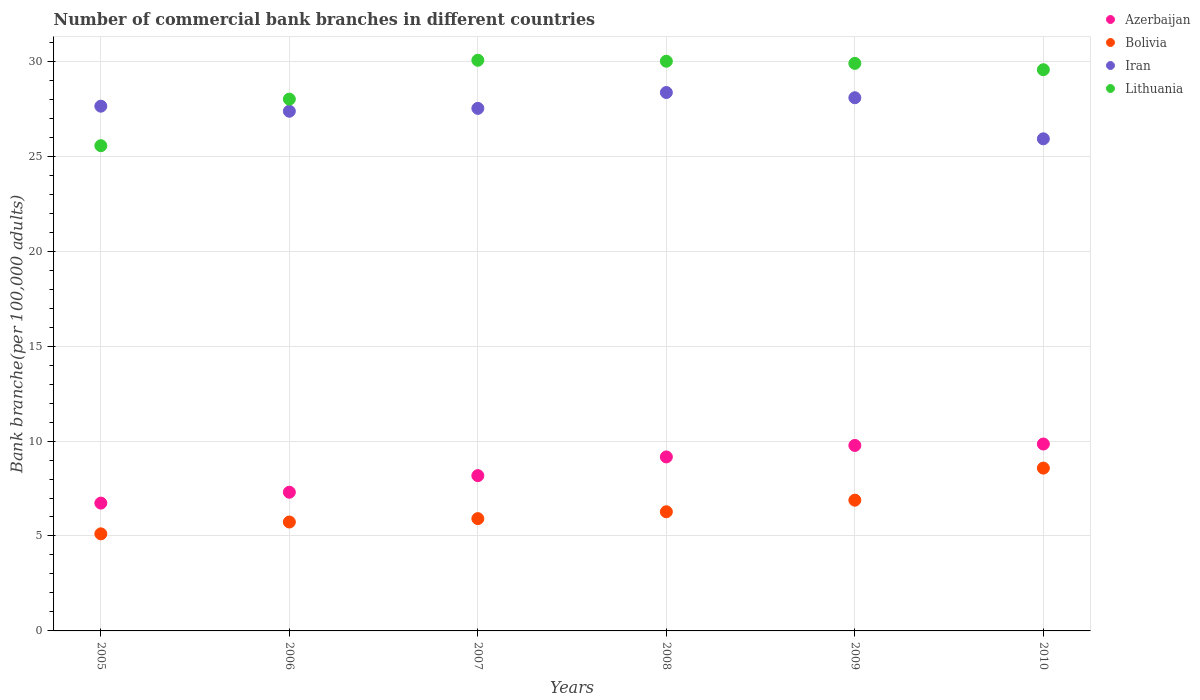How many different coloured dotlines are there?
Your response must be concise. 4. Is the number of dotlines equal to the number of legend labels?
Offer a very short reply. Yes. What is the number of commercial bank branches in Bolivia in 2005?
Make the answer very short. 5.11. Across all years, what is the maximum number of commercial bank branches in Bolivia?
Provide a short and direct response. 8.57. Across all years, what is the minimum number of commercial bank branches in Azerbaijan?
Keep it short and to the point. 6.73. In which year was the number of commercial bank branches in Lithuania maximum?
Offer a terse response. 2007. What is the total number of commercial bank branches in Iran in the graph?
Make the answer very short. 164.88. What is the difference between the number of commercial bank branches in Azerbaijan in 2005 and that in 2006?
Your answer should be compact. -0.57. What is the difference between the number of commercial bank branches in Azerbaijan in 2007 and the number of commercial bank branches in Bolivia in 2009?
Your answer should be compact. 1.29. What is the average number of commercial bank branches in Iran per year?
Your answer should be very brief. 27.48. In the year 2007, what is the difference between the number of commercial bank branches in Bolivia and number of commercial bank branches in Iran?
Ensure brevity in your answer.  -21.61. What is the ratio of the number of commercial bank branches in Lithuania in 2005 to that in 2007?
Offer a terse response. 0.85. What is the difference between the highest and the second highest number of commercial bank branches in Bolivia?
Ensure brevity in your answer.  1.69. What is the difference between the highest and the lowest number of commercial bank branches in Azerbaijan?
Your response must be concise. 3.11. In how many years, is the number of commercial bank branches in Bolivia greater than the average number of commercial bank branches in Bolivia taken over all years?
Make the answer very short. 2. Is it the case that in every year, the sum of the number of commercial bank branches in Lithuania and number of commercial bank branches in Iran  is greater than the sum of number of commercial bank branches in Bolivia and number of commercial bank branches in Azerbaijan?
Give a very brief answer. No. Does the number of commercial bank branches in Iran monotonically increase over the years?
Offer a very short reply. No. Is the number of commercial bank branches in Iran strictly greater than the number of commercial bank branches in Azerbaijan over the years?
Give a very brief answer. Yes. Is the number of commercial bank branches in Bolivia strictly less than the number of commercial bank branches in Azerbaijan over the years?
Your answer should be very brief. Yes. How many dotlines are there?
Make the answer very short. 4. How many years are there in the graph?
Ensure brevity in your answer.  6. Are the values on the major ticks of Y-axis written in scientific E-notation?
Your response must be concise. No. Does the graph contain grids?
Offer a terse response. Yes. Where does the legend appear in the graph?
Ensure brevity in your answer.  Top right. How many legend labels are there?
Give a very brief answer. 4. How are the legend labels stacked?
Give a very brief answer. Vertical. What is the title of the graph?
Offer a terse response. Number of commercial bank branches in different countries. Does "Senegal" appear as one of the legend labels in the graph?
Your answer should be very brief. No. What is the label or title of the Y-axis?
Give a very brief answer. Bank branche(per 100,0 adults). What is the Bank branche(per 100,000 adults) of Azerbaijan in 2005?
Offer a terse response. 6.73. What is the Bank branche(per 100,000 adults) in Bolivia in 2005?
Offer a terse response. 5.11. What is the Bank branche(per 100,000 adults) in Iran in 2005?
Give a very brief answer. 27.64. What is the Bank branche(per 100,000 adults) in Lithuania in 2005?
Give a very brief answer. 25.55. What is the Bank branche(per 100,000 adults) in Azerbaijan in 2006?
Ensure brevity in your answer.  7.3. What is the Bank branche(per 100,000 adults) in Bolivia in 2006?
Ensure brevity in your answer.  5.74. What is the Bank branche(per 100,000 adults) of Iran in 2006?
Your answer should be compact. 27.37. What is the Bank branche(per 100,000 adults) of Lithuania in 2006?
Your answer should be compact. 28.01. What is the Bank branche(per 100,000 adults) of Azerbaijan in 2007?
Give a very brief answer. 8.18. What is the Bank branche(per 100,000 adults) of Bolivia in 2007?
Provide a short and direct response. 5.91. What is the Bank branche(per 100,000 adults) of Iran in 2007?
Offer a very short reply. 27.52. What is the Bank branche(per 100,000 adults) in Lithuania in 2007?
Make the answer very short. 30.05. What is the Bank branche(per 100,000 adults) of Azerbaijan in 2008?
Give a very brief answer. 9.16. What is the Bank branche(per 100,000 adults) in Bolivia in 2008?
Provide a short and direct response. 6.28. What is the Bank branche(per 100,000 adults) in Iran in 2008?
Keep it short and to the point. 28.36. What is the Bank branche(per 100,000 adults) of Lithuania in 2008?
Your answer should be very brief. 30. What is the Bank branche(per 100,000 adults) in Azerbaijan in 2009?
Provide a short and direct response. 9.77. What is the Bank branche(per 100,000 adults) of Bolivia in 2009?
Give a very brief answer. 6.89. What is the Bank branche(per 100,000 adults) in Iran in 2009?
Keep it short and to the point. 28.08. What is the Bank branche(per 100,000 adults) in Lithuania in 2009?
Make the answer very short. 29.89. What is the Bank branche(per 100,000 adults) of Azerbaijan in 2010?
Make the answer very short. 9.84. What is the Bank branche(per 100,000 adults) of Bolivia in 2010?
Provide a short and direct response. 8.57. What is the Bank branche(per 100,000 adults) in Iran in 2010?
Provide a short and direct response. 25.92. What is the Bank branche(per 100,000 adults) of Lithuania in 2010?
Provide a short and direct response. 29.56. Across all years, what is the maximum Bank branche(per 100,000 adults) in Azerbaijan?
Give a very brief answer. 9.84. Across all years, what is the maximum Bank branche(per 100,000 adults) of Bolivia?
Ensure brevity in your answer.  8.57. Across all years, what is the maximum Bank branche(per 100,000 adults) of Iran?
Offer a terse response. 28.36. Across all years, what is the maximum Bank branche(per 100,000 adults) of Lithuania?
Offer a terse response. 30.05. Across all years, what is the minimum Bank branche(per 100,000 adults) in Azerbaijan?
Your answer should be compact. 6.73. Across all years, what is the minimum Bank branche(per 100,000 adults) of Bolivia?
Make the answer very short. 5.11. Across all years, what is the minimum Bank branche(per 100,000 adults) of Iran?
Your answer should be very brief. 25.92. Across all years, what is the minimum Bank branche(per 100,000 adults) of Lithuania?
Offer a terse response. 25.55. What is the total Bank branche(per 100,000 adults) of Azerbaijan in the graph?
Provide a short and direct response. 50.99. What is the total Bank branche(per 100,000 adults) of Bolivia in the graph?
Offer a very short reply. 38.5. What is the total Bank branche(per 100,000 adults) in Iran in the graph?
Provide a succinct answer. 164.88. What is the total Bank branche(per 100,000 adults) of Lithuania in the graph?
Make the answer very short. 173.07. What is the difference between the Bank branche(per 100,000 adults) in Azerbaijan in 2005 and that in 2006?
Give a very brief answer. -0.57. What is the difference between the Bank branche(per 100,000 adults) in Bolivia in 2005 and that in 2006?
Provide a short and direct response. -0.62. What is the difference between the Bank branche(per 100,000 adults) in Iran in 2005 and that in 2006?
Provide a short and direct response. 0.27. What is the difference between the Bank branche(per 100,000 adults) in Lithuania in 2005 and that in 2006?
Make the answer very short. -2.45. What is the difference between the Bank branche(per 100,000 adults) of Azerbaijan in 2005 and that in 2007?
Offer a terse response. -1.45. What is the difference between the Bank branche(per 100,000 adults) in Bolivia in 2005 and that in 2007?
Give a very brief answer. -0.8. What is the difference between the Bank branche(per 100,000 adults) of Iran in 2005 and that in 2007?
Keep it short and to the point. 0.12. What is the difference between the Bank branche(per 100,000 adults) in Azerbaijan in 2005 and that in 2008?
Make the answer very short. -2.43. What is the difference between the Bank branche(per 100,000 adults) of Bolivia in 2005 and that in 2008?
Make the answer very short. -1.16. What is the difference between the Bank branche(per 100,000 adults) in Iran in 2005 and that in 2008?
Make the answer very short. -0.72. What is the difference between the Bank branche(per 100,000 adults) in Lithuania in 2005 and that in 2008?
Offer a very short reply. -4.45. What is the difference between the Bank branche(per 100,000 adults) in Azerbaijan in 2005 and that in 2009?
Your response must be concise. -3.04. What is the difference between the Bank branche(per 100,000 adults) in Bolivia in 2005 and that in 2009?
Keep it short and to the point. -1.77. What is the difference between the Bank branche(per 100,000 adults) in Iran in 2005 and that in 2009?
Your answer should be very brief. -0.44. What is the difference between the Bank branche(per 100,000 adults) of Lithuania in 2005 and that in 2009?
Make the answer very short. -4.34. What is the difference between the Bank branche(per 100,000 adults) of Azerbaijan in 2005 and that in 2010?
Ensure brevity in your answer.  -3.11. What is the difference between the Bank branche(per 100,000 adults) of Bolivia in 2005 and that in 2010?
Your answer should be compact. -3.46. What is the difference between the Bank branche(per 100,000 adults) in Iran in 2005 and that in 2010?
Your response must be concise. 1.72. What is the difference between the Bank branche(per 100,000 adults) in Lithuania in 2005 and that in 2010?
Ensure brevity in your answer.  -4. What is the difference between the Bank branche(per 100,000 adults) of Azerbaijan in 2006 and that in 2007?
Your answer should be very brief. -0.87. What is the difference between the Bank branche(per 100,000 adults) in Bolivia in 2006 and that in 2007?
Provide a succinct answer. -0.18. What is the difference between the Bank branche(per 100,000 adults) in Iran in 2006 and that in 2007?
Keep it short and to the point. -0.15. What is the difference between the Bank branche(per 100,000 adults) in Lithuania in 2006 and that in 2007?
Your response must be concise. -2.05. What is the difference between the Bank branche(per 100,000 adults) of Azerbaijan in 2006 and that in 2008?
Your response must be concise. -1.86. What is the difference between the Bank branche(per 100,000 adults) of Bolivia in 2006 and that in 2008?
Ensure brevity in your answer.  -0.54. What is the difference between the Bank branche(per 100,000 adults) of Iran in 2006 and that in 2008?
Provide a short and direct response. -0.99. What is the difference between the Bank branche(per 100,000 adults) of Lithuania in 2006 and that in 2008?
Your answer should be very brief. -2. What is the difference between the Bank branche(per 100,000 adults) in Azerbaijan in 2006 and that in 2009?
Give a very brief answer. -2.46. What is the difference between the Bank branche(per 100,000 adults) of Bolivia in 2006 and that in 2009?
Keep it short and to the point. -1.15. What is the difference between the Bank branche(per 100,000 adults) of Iran in 2006 and that in 2009?
Ensure brevity in your answer.  -0.71. What is the difference between the Bank branche(per 100,000 adults) of Lithuania in 2006 and that in 2009?
Offer a terse response. -1.88. What is the difference between the Bank branche(per 100,000 adults) in Azerbaijan in 2006 and that in 2010?
Offer a very short reply. -2.54. What is the difference between the Bank branche(per 100,000 adults) of Bolivia in 2006 and that in 2010?
Your answer should be very brief. -2.84. What is the difference between the Bank branche(per 100,000 adults) of Iran in 2006 and that in 2010?
Provide a short and direct response. 1.45. What is the difference between the Bank branche(per 100,000 adults) of Lithuania in 2006 and that in 2010?
Make the answer very short. -1.55. What is the difference between the Bank branche(per 100,000 adults) in Azerbaijan in 2007 and that in 2008?
Give a very brief answer. -0.98. What is the difference between the Bank branche(per 100,000 adults) of Bolivia in 2007 and that in 2008?
Provide a succinct answer. -0.36. What is the difference between the Bank branche(per 100,000 adults) in Iran in 2007 and that in 2008?
Keep it short and to the point. -0.84. What is the difference between the Bank branche(per 100,000 adults) in Lithuania in 2007 and that in 2008?
Provide a succinct answer. 0.05. What is the difference between the Bank branche(per 100,000 adults) in Azerbaijan in 2007 and that in 2009?
Your answer should be very brief. -1.59. What is the difference between the Bank branche(per 100,000 adults) in Bolivia in 2007 and that in 2009?
Provide a succinct answer. -0.97. What is the difference between the Bank branche(per 100,000 adults) of Iran in 2007 and that in 2009?
Ensure brevity in your answer.  -0.56. What is the difference between the Bank branche(per 100,000 adults) of Lithuania in 2007 and that in 2009?
Provide a short and direct response. 0.16. What is the difference between the Bank branche(per 100,000 adults) in Azerbaijan in 2007 and that in 2010?
Keep it short and to the point. -1.66. What is the difference between the Bank branche(per 100,000 adults) in Bolivia in 2007 and that in 2010?
Offer a very short reply. -2.66. What is the difference between the Bank branche(per 100,000 adults) in Iran in 2007 and that in 2010?
Ensure brevity in your answer.  1.6. What is the difference between the Bank branche(per 100,000 adults) in Lithuania in 2007 and that in 2010?
Your response must be concise. 0.5. What is the difference between the Bank branche(per 100,000 adults) in Azerbaijan in 2008 and that in 2009?
Your answer should be very brief. -0.6. What is the difference between the Bank branche(per 100,000 adults) of Bolivia in 2008 and that in 2009?
Provide a short and direct response. -0.61. What is the difference between the Bank branche(per 100,000 adults) of Iran in 2008 and that in 2009?
Your response must be concise. 0.28. What is the difference between the Bank branche(per 100,000 adults) of Lithuania in 2008 and that in 2009?
Your answer should be very brief. 0.11. What is the difference between the Bank branche(per 100,000 adults) in Azerbaijan in 2008 and that in 2010?
Your response must be concise. -0.68. What is the difference between the Bank branche(per 100,000 adults) in Bolivia in 2008 and that in 2010?
Your response must be concise. -2.3. What is the difference between the Bank branche(per 100,000 adults) of Iran in 2008 and that in 2010?
Provide a succinct answer. 2.44. What is the difference between the Bank branche(per 100,000 adults) of Lithuania in 2008 and that in 2010?
Offer a very short reply. 0.45. What is the difference between the Bank branche(per 100,000 adults) in Azerbaijan in 2009 and that in 2010?
Offer a very short reply. -0.07. What is the difference between the Bank branche(per 100,000 adults) in Bolivia in 2009 and that in 2010?
Your answer should be compact. -1.69. What is the difference between the Bank branche(per 100,000 adults) of Iran in 2009 and that in 2010?
Your response must be concise. 2.16. What is the difference between the Bank branche(per 100,000 adults) of Lithuania in 2009 and that in 2010?
Your response must be concise. 0.33. What is the difference between the Bank branche(per 100,000 adults) in Azerbaijan in 2005 and the Bank branche(per 100,000 adults) in Bolivia in 2006?
Keep it short and to the point. 1. What is the difference between the Bank branche(per 100,000 adults) of Azerbaijan in 2005 and the Bank branche(per 100,000 adults) of Iran in 2006?
Your response must be concise. -20.64. What is the difference between the Bank branche(per 100,000 adults) in Azerbaijan in 2005 and the Bank branche(per 100,000 adults) in Lithuania in 2006?
Make the answer very short. -21.28. What is the difference between the Bank branche(per 100,000 adults) in Bolivia in 2005 and the Bank branche(per 100,000 adults) in Iran in 2006?
Keep it short and to the point. -22.26. What is the difference between the Bank branche(per 100,000 adults) of Bolivia in 2005 and the Bank branche(per 100,000 adults) of Lithuania in 2006?
Offer a terse response. -22.9. What is the difference between the Bank branche(per 100,000 adults) in Iran in 2005 and the Bank branche(per 100,000 adults) in Lithuania in 2006?
Your answer should be compact. -0.37. What is the difference between the Bank branche(per 100,000 adults) of Azerbaijan in 2005 and the Bank branche(per 100,000 adults) of Bolivia in 2007?
Keep it short and to the point. 0.82. What is the difference between the Bank branche(per 100,000 adults) in Azerbaijan in 2005 and the Bank branche(per 100,000 adults) in Iran in 2007?
Make the answer very short. -20.79. What is the difference between the Bank branche(per 100,000 adults) of Azerbaijan in 2005 and the Bank branche(per 100,000 adults) of Lithuania in 2007?
Your answer should be compact. -23.32. What is the difference between the Bank branche(per 100,000 adults) of Bolivia in 2005 and the Bank branche(per 100,000 adults) of Iran in 2007?
Ensure brevity in your answer.  -22.41. What is the difference between the Bank branche(per 100,000 adults) in Bolivia in 2005 and the Bank branche(per 100,000 adults) in Lithuania in 2007?
Make the answer very short. -24.94. What is the difference between the Bank branche(per 100,000 adults) of Iran in 2005 and the Bank branche(per 100,000 adults) of Lithuania in 2007?
Your answer should be compact. -2.42. What is the difference between the Bank branche(per 100,000 adults) of Azerbaijan in 2005 and the Bank branche(per 100,000 adults) of Bolivia in 2008?
Make the answer very short. 0.46. What is the difference between the Bank branche(per 100,000 adults) of Azerbaijan in 2005 and the Bank branche(per 100,000 adults) of Iran in 2008?
Your response must be concise. -21.62. What is the difference between the Bank branche(per 100,000 adults) in Azerbaijan in 2005 and the Bank branche(per 100,000 adults) in Lithuania in 2008?
Your response must be concise. -23.27. What is the difference between the Bank branche(per 100,000 adults) in Bolivia in 2005 and the Bank branche(per 100,000 adults) in Iran in 2008?
Keep it short and to the point. -23.24. What is the difference between the Bank branche(per 100,000 adults) of Bolivia in 2005 and the Bank branche(per 100,000 adults) of Lithuania in 2008?
Give a very brief answer. -24.89. What is the difference between the Bank branche(per 100,000 adults) of Iran in 2005 and the Bank branche(per 100,000 adults) of Lithuania in 2008?
Ensure brevity in your answer.  -2.37. What is the difference between the Bank branche(per 100,000 adults) of Azerbaijan in 2005 and the Bank branche(per 100,000 adults) of Bolivia in 2009?
Ensure brevity in your answer.  -0.15. What is the difference between the Bank branche(per 100,000 adults) in Azerbaijan in 2005 and the Bank branche(per 100,000 adults) in Iran in 2009?
Give a very brief answer. -21.35. What is the difference between the Bank branche(per 100,000 adults) in Azerbaijan in 2005 and the Bank branche(per 100,000 adults) in Lithuania in 2009?
Your answer should be very brief. -23.16. What is the difference between the Bank branche(per 100,000 adults) in Bolivia in 2005 and the Bank branche(per 100,000 adults) in Iran in 2009?
Your response must be concise. -22.97. What is the difference between the Bank branche(per 100,000 adults) of Bolivia in 2005 and the Bank branche(per 100,000 adults) of Lithuania in 2009?
Offer a terse response. -24.78. What is the difference between the Bank branche(per 100,000 adults) in Iran in 2005 and the Bank branche(per 100,000 adults) in Lithuania in 2009?
Give a very brief answer. -2.25. What is the difference between the Bank branche(per 100,000 adults) in Azerbaijan in 2005 and the Bank branche(per 100,000 adults) in Bolivia in 2010?
Provide a short and direct response. -1.84. What is the difference between the Bank branche(per 100,000 adults) in Azerbaijan in 2005 and the Bank branche(per 100,000 adults) in Iran in 2010?
Give a very brief answer. -19.19. What is the difference between the Bank branche(per 100,000 adults) in Azerbaijan in 2005 and the Bank branche(per 100,000 adults) in Lithuania in 2010?
Give a very brief answer. -22.82. What is the difference between the Bank branche(per 100,000 adults) of Bolivia in 2005 and the Bank branche(per 100,000 adults) of Iran in 2010?
Ensure brevity in your answer.  -20.8. What is the difference between the Bank branche(per 100,000 adults) in Bolivia in 2005 and the Bank branche(per 100,000 adults) in Lithuania in 2010?
Make the answer very short. -24.44. What is the difference between the Bank branche(per 100,000 adults) of Iran in 2005 and the Bank branche(per 100,000 adults) of Lithuania in 2010?
Give a very brief answer. -1.92. What is the difference between the Bank branche(per 100,000 adults) of Azerbaijan in 2006 and the Bank branche(per 100,000 adults) of Bolivia in 2007?
Provide a short and direct response. 1.39. What is the difference between the Bank branche(per 100,000 adults) in Azerbaijan in 2006 and the Bank branche(per 100,000 adults) in Iran in 2007?
Offer a very short reply. -20.22. What is the difference between the Bank branche(per 100,000 adults) in Azerbaijan in 2006 and the Bank branche(per 100,000 adults) in Lithuania in 2007?
Ensure brevity in your answer.  -22.75. What is the difference between the Bank branche(per 100,000 adults) of Bolivia in 2006 and the Bank branche(per 100,000 adults) of Iran in 2007?
Give a very brief answer. -21.78. What is the difference between the Bank branche(per 100,000 adults) of Bolivia in 2006 and the Bank branche(per 100,000 adults) of Lithuania in 2007?
Make the answer very short. -24.32. What is the difference between the Bank branche(per 100,000 adults) of Iran in 2006 and the Bank branche(per 100,000 adults) of Lithuania in 2007?
Provide a short and direct response. -2.69. What is the difference between the Bank branche(per 100,000 adults) of Azerbaijan in 2006 and the Bank branche(per 100,000 adults) of Bolivia in 2008?
Your answer should be very brief. 1.03. What is the difference between the Bank branche(per 100,000 adults) in Azerbaijan in 2006 and the Bank branche(per 100,000 adults) in Iran in 2008?
Provide a short and direct response. -21.05. What is the difference between the Bank branche(per 100,000 adults) in Azerbaijan in 2006 and the Bank branche(per 100,000 adults) in Lithuania in 2008?
Your answer should be compact. -22.7. What is the difference between the Bank branche(per 100,000 adults) in Bolivia in 2006 and the Bank branche(per 100,000 adults) in Iran in 2008?
Offer a terse response. -22.62. What is the difference between the Bank branche(per 100,000 adults) in Bolivia in 2006 and the Bank branche(per 100,000 adults) in Lithuania in 2008?
Your answer should be very brief. -24.27. What is the difference between the Bank branche(per 100,000 adults) in Iran in 2006 and the Bank branche(per 100,000 adults) in Lithuania in 2008?
Ensure brevity in your answer.  -2.63. What is the difference between the Bank branche(per 100,000 adults) in Azerbaijan in 2006 and the Bank branche(per 100,000 adults) in Bolivia in 2009?
Your response must be concise. 0.42. What is the difference between the Bank branche(per 100,000 adults) of Azerbaijan in 2006 and the Bank branche(per 100,000 adults) of Iran in 2009?
Offer a terse response. -20.78. What is the difference between the Bank branche(per 100,000 adults) in Azerbaijan in 2006 and the Bank branche(per 100,000 adults) in Lithuania in 2009?
Offer a very short reply. -22.59. What is the difference between the Bank branche(per 100,000 adults) in Bolivia in 2006 and the Bank branche(per 100,000 adults) in Iran in 2009?
Keep it short and to the point. -22.35. What is the difference between the Bank branche(per 100,000 adults) in Bolivia in 2006 and the Bank branche(per 100,000 adults) in Lithuania in 2009?
Keep it short and to the point. -24.15. What is the difference between the Bank branche(per 100,000 adults) in Iran in 2006 and the Bank branche(per 100,000 adults) in Lithuania in 2009?
Your answer should be compact. -2.52. What is the difference between the Bank branche(per 100,000 adults) of Azerbaijan in 2006 and the Bank branche(per 100,000 adults) of Bolivia in 2010?
Offer a terse response. -1.27. What is the difference between the Bank branche(per 100,000 adults) of Azerbaijan in 2006 and the Bank branche(per 100,000 adults) of Iran in 2010?
Ensure brevity in your answer.  -18.61. What is the difference between the Bank branche(per 100,000 adults) of Azerbaijan in 2006 and the Bank branche(per 100,000 adults) of Lithuania in 2010?
Give a very brief answer. -22.25. What is the difference between the Bank branche(per 100,000 adults) in Bolivia in 2006 and the Bank branche(per 100,000 adults) in Iran in 2010?
Make the answer very short. -20.18. What is the difference between the Bank branche(per 100,000 adults) of Bolivia in 2006 and the Bank branche(per 100,000 adults) of Lithuania in 2010?
Give a very brief answer. -23.82. What is the difference between the Bank branche(per 100,000 adults) in Iran in 2006 and the Bank branche(per 100,000 adults) in Lithuania in 2010?
Offer a very short reply. -2.19. What is the difference between the Bank branche(per 100,000 adults) of Azerbaijan in 2007 and the Bank branche(per 100,000 adults) of Bolivia in 2008?
Your answer should be compact. 1.9. What is the difference between the Bank branche(per 100,000 adults) of Azerbaijan in 2007 and the Bank branche(per 100,000 adults) of Iran in 2008?
Your response must be concise. -20.18. What is the difference between the Bank branche(per 100,000 adults) of Azerbaijan in 2007 and the Bank branche(per 100,000 adults) of Lithuania in 2008?
Provide a succinct answer. -21.82. What is the difference between the Bank branche(per 100,000 adults) of Bolivia in 2007 and the Bank branche(per 100,000 adults) of Iran in 2008?
Your answer should be very brief. -22.44. What is the difference between the Bank branche(per 100,000 adults) of Bolivia in 2007 and the Bank branche(per 100,000 adults) of Lithuania in 2008?
Your answer should be very brief. -24.09. What is the difference between the Bank branche(per 100,000 adults) in Iran in 2007 and the Bank branche(per 100,000 adults) in Lithuania in 2008?
Offer a very short reply. -2.48. What is the difference between the Bank branche(per 100,000 adults) in Azerbaijan in 2007 and the Bank branche(per 100,000 adults) in Bolivia in 2009?
Give a very brief answer. 1.29. What is the difference between the Bank branche(per 100,000 adults) in Azerbaijan in 2007 and the Bank branche(per 100,000 adults) in Iran in 2009?
Your response must be concise. -19.9. What is the difference between the Bank branche(per 100,000 adults) in Azerbaijan in 2007 and the Bank branche(per 100,000 adults) in Lithuania in 2009?
Offer a terse response. -21.71. What is the difference between the Bank branche(per 100,000 adults) of Bolivia in 2007 and the Bank branche(per 100,000 adults) of Iran in 2009?
Give a very brief answer. -22.17. What is the difference between the Bank branche(per 100,000 adults) in Bolivia in 2007 and the Bank branche(per 100,000 adults) in Lithuania in 2009?
Provide a short and direct response. -23.98. What is the difference between the Bank branche(per 100,000 adults) of Iran in 2007 and the Bank branche(per 100,000 adults) of Lithuania in 2009?
Give a very brief answer. -2.37. What is the difference between the Bank branche(per 100,000 adults) in Azerbaijan in 2007 and the Bank branche(per 100,000 adults) in Bolivia in 2010?
Your answer should be very brief. -0.4. What is the difference between the Bank branche(per 100,000 adults) of Azerbaijan in 2007 and the Bank branche(per 100,000 adults) of Iran in 2010?
Provide a short and direct response. -17.74. What is the difference between the Bank branche(per 100,000 adults) in Azerbaijan in 2007 and the Bank branche(per 100,000 adults) in Lithuania in 2010?
Your answer should be very brief. -21.38. What is the difference between the Bank branche(per 100,000 adults) of Bolivia in 2007 and the Bank branche(per 100,000 adults) of Iran in 2010?
Keep it short and to the point. -20. What is the difference between the Bank branche(per 100,000 adults) of Bolivia in 2007 and the Bank branche(per 100,000 adults) of Lithuania in 2010?
Ensure brevity in your answer.  -23.64. What is the difference between the Bank branche(per 100,000 adults) of Iran in 2007 and the Bank branche(per 100,000 adults) of Lithuania in 2010?
Give a very brief answer. -2.04. What is the difference between the Bank branche(per 100,000 adults) in Azerbaijan in 2008 and the Bank branche(per 100,000 adults) in Bolivia in 2009?
Offer a terse response. 2.28. What is the difference between the Bank branche(per 100,000 adults) in Azerbaijan in 2008 and the Bank branche(per 100,000 adults) in Iran in 2009?
Provide a short and direct response. -18.92. What is the difference between the Bank branche(per 100,000 adults) in Azerbaijan in 2008 and the Bank branche(per 100,000 adults) in Lithuania in 2009?
Provide a short and direct response. -20.73. What is the difference between the Bank branche(per 100,000 adults) in Bolivia in 2008 and the Bank branche(per 100,000 adults) in Iran in 2009?
Give a very brief answer. -21.81. What is the difference between the Bank branche(per 100,000 adults) of Bolivia in 2008 and the Bank branche(per 100,000 adults) of Lithuania in 2009?
Make the answer very short. -23.61. What is the difference between the Bank branche(per 100,000 adults) of Iran in 2008 and the Bank branche(per 100,000 adults) of Lithuania in 2009?
Your answer should be compact. -1.53. What is the difference between the Bank branche(per 100,000 adults) of Azerbaijan in 2008 and the Bank branche(per 100,000 adults) of Bolivia in 2010?
Your answer should be compact. 0.59. What is the difference between the Bank branche(per 100,000 adults) in Azerbaijan in 2008 and the Bank branche(per 100,000 adults) in Iran in 2010?
Provide a short and direct response. -16.75. What is the difference between the Bank branche(per 100,000 adults) of Azerbaijan in 2008 and the Bank branche(per 100,000 adults) of Lithuania in 2010?
Give a very brief answer. -20.39. What is the difference between the Bank branche(per 100,000 adults) in Bolivia in 2008 and the Bank branche(per 100,000 adults) in Iran in 2010?
Provide a short and direct response. -19.64. What is the difference between the Bank branche(per 100,000 adults) of Bolivia in 2008 and the Bank branche(per 100,000 adults) of Lithuania in 2010?
Make the answer very short. -23.28. What is the difference between the Bank branche(per 100,000 adults) of Iran in 2008 and the Bank branche(per 100,000 adults) of Lithuania in 2010?
Your answer should be very brief. -1.2. What is the difference between the Bank branche(per 100,000 adults) of Azerbaijan in 2009 and the Bank branche(per 100,000 adults) of Bolivia in 2010?
Your response must be concise. 1.19. What is the difference between the Bank branche(per 100,000 adults) in Azerbaijan in 2009 and the Bank branche(per 100,000 adults) in Iran in 2010?
Provide a short and direct response. -16.15. What is the difference between the Bank branche(per 100,000 adults) in Azerbaijan in 2009 and the Bank branche(per 100,000 adults) in Lithuania in 2010?
Offer a very short reply. -19.79. What is the difference between the Bank branche(per 100,000 adults) in Bolivia in 2009 and the Bank branche(per 100,000 adults) in Iran in 2010?
Ensure brevity in your answer.  -19.03. What is the difference between the Bank branche(per 100,000 adults) of Bolivia in 2009 and the Bank branche(per 100,000 adults) of Lithuania in 2010?
Make the answer very short. -22.67. What is the difference between the Bank branche(per 100,000 adults) of Iran in 2009 and the Bank branche(per 100,000 adults) of Lithuania in 2010?
Provide a succinct answer. -1.48. What is the average Bank branche(per 100,000 adults) of Azerbaijan per year?
Give a very brief answer. 8.5. What is the average Bank branche(per 100,000 adults) of Bolivia per year?
Offer a very short reply. 6.42. What is the average Bank branche(per 100,000 adults) in Iran per year?
Offer a very short reply. 27.48. What is the average Bank branche(per 100,000 adults) in Lithuania per year?
Ensure brevity in your answer.  28.84. In the year 2005, what is the difference between the Bank branche(per 100,000 adults) of Azerbaijan and Bank branche(per 100,000 adults) of Bolivia?
Your answer should be very brief. 1.62. In the year 2005, what is the difference between the Bank branche(per 100,000 adults) of Azerbaijan and Bank branche(per 100,000 adults) of Iran?
Provide a short and direct response. -20.9. In the year 2005, what is the difference between the Bank branche(per 100,000 adults) of Azerbaijan and Bank branche(per 100,000 adults) of Lithuania?
Make the answer very short. -18.82. In the year 2005, what is the difference between the Bank branche(per 100,000 adults) of Bolivia and Bank branche(per 100,000 adults) of Iran?
Your response must be concise. -22.52. In the year 2005, what is the difference between the Bank branche(per 100,000 adults) of Bolivia and Bank branche(per 100,000 adults) of Lithuania?
Ensure brevity in your answer.  -20.44. In the year 2005, what is the difference between the Bank branche(per 100,000 adults) in Iran and Bank branche(per 100,000 adults) in Lithuania?
Offer a terse response. 2.08. In the year 2006, what is the difference between the Bank branche(per 100,000 adults) in Azerbaijan and Bank branche(per 100,000 adults) in Bolivia?
Your answer should be compact. 1.57. In the year 2006, what is the difference between the Bank branche(per 100,000 adults) in Azerbaijan and Bank branche(per 100,000 adults) in Iran?
Your answer should be compact. -20.07. In the year 2006, what is the difference between the Bank branche(per 100,000 adults) in Azerbaijan and Bank branche(per 100,000 adults) in Lithuania?
Your answer should be compact. -20.7. In the year 2006, what is the difference between the Bank branche(per 100,000 adults) in Bolivia and Bank branche(per 100,000 adults) in Iran?
Keep it short and to the point. -21.63. In the year 2006, what is the difference between the Bank branche(per 100,000 adults) in Bolivia and Bank branche(per 100,000 adults) in Lithuania?
Provide a succinct answer. -22.27. In the year 2006, what is the difference between the Bank branche(per 100,000 adults) of Iran and Bank branche(per 100,000 adults) of Lithuania?
Give a very brief answer. -0.64. In the year 2007, what is the difference between the Bank branche(per 100,000 adults) of Azerbaijan and Bank branche(per 100,000 adults) of Bolivia?
Make the answer very short. 2.26. In the year 2007, what is the difference between the Bank branche(per 100,000 adults) of Azerbaijan and Bank branche(per 100,000 adults) of Iran?
Your answer should be very brief. -19.34. In the year 2007, what is the difference between the Bank branche(per 100,000 adults) in Azerbaijan and Bank branche(per 100,000 adults) in Lithuania?
Your answer should be very brief. -21.88. In the year 2007, what is the difference between the Bank branche(per 100,000 adults) of Bolivia and Bank branche(per 100,000 adults) of Iran?
Provide a short and direct response. -21.61. In the year 2007, what is the difference between the Bank branche(per 100,000 adults) in Bolivia and Bank branche(per 100,000 adults) in Lithuania?
Your response must be concise. -24.14. In the year 2007, what is the difference between the Bank branche(per 100,000 adults) of Iran and Bank branche(per 100,000 adults) of Lithuania?
Provide a short and direct response. -2.53. In the year 2008, what is the difference between the Bank branche(per 100,000 adults) of Azerbaijan and Bank branche(per 100,000 adults) of Bolivia?
Provide a short and direct response. 2.89. In the year 2008, what is the difference between the Bank branche(per 100,000 adults) in Azerbaijan and Bank branche(per 100,000 adults) in Iran?
Ensure brevity in your answer.  -19.19. In the year 2008, what is the difference between the Bank branche(per 100,000 adults) in Azerbaijan and Bank branche(per 100,000 adults) in Lithuania?
Provide a succinct answer. -20.84. In the year 2008, what is the difference between the Bank branche(per 100,000 adults) in Bolivia and Bank branche(per 100,000 adults) in Iran?
Give a very brief answer. -22.08. In the year 2008, what is the difference between the Bank branche(per 100,000 adults) in Bolivia and Bank branche(per 100,000 adults) in Lithuania?
Your answer should be very brief. -23.73. In the year 2008, what is the difference between the Bank branche(per 100,000 adults) in Iran and Bank branche(per 100,000 adults) in Lithuania?
Your response must be concise. -1.65. In the year 2009, what is the difference between the Bank branche(per 100,000 adults) in Azerbaijan and Bank branche(per 100,000 adults) in Bolivia?
Provide a short and direct response. 2.88. In the year 2009, what is the difference between the Bank branche(per 100,000 adults) in Azerbaijan and Bank branche(per 100,000 adults) in Iran?
Make the answer very short. -18.31. In the year 2009, what is the difference between the Bank branche(per 100,000 adults) in Azerbaijan and Bank branche(per 100,000 adults) in Lithuania?
Make the answer very short. -20.12. In the year 2009, what is the difference between the Bank branche(per 100,000 adults) in Bolivia and Bank branche(per 100,000 adults) in Iran?
Provide a short and direct response. -21.2. In the year 2009, what is the difference between the Bank branche(per 100,000 adults) of Bolivia and Bank branche(per 100,000 adults) of Lithuania?
Keep it short and to the point. -23. In the year 2009, what is the difference between the Bank branche(per 100,000 adults) in Iran and Bank branche(per 100,000 adults) in Lithuania?
Offer a terse response. -1.81. In the year 2010, what is the difference between the Bank branche(per 100,000 adults) of Azerbaijan and Bank branche(per 100,000 adults) of Bolivia?
Keep it short and to the point. 1.27. In the year 2010, what is the difference between the Bank branche(per 100,000 adults) of Azerbaijan and Bank branche(per 100,000 adults) of Iran?
Your answer should be compact. -16.07. In the year 2010, what is the difference between the Bank branche(per 100,000 adults) in Azerbaijan and Bank branche(per 100,000 adults) in Lithuania?
Your answer should be very brief. -19.71. In the year 2010, what is the difference between the Bank branche(per 100,000 adults) in Bolivia and Bank branche(per 100,000 adults) in Iran?
Make the answer very short. -17.34. In the year 2010, what is the difference between the Bank branche(per 100,000 adults) in Bolivia and Bank branche(per 100,000 adults) in Lithuania?
Make the answer very short. -20.98. In the year 2010, what is the difference between the Bank branche(per 100,000 adults) in Iran and Bank branche(per 100,000 adults) in Lithuania?
Your answer should be compact. -3.64. What is the ratio of the Bank branche(per 100,000 adults) of Azerbaijan in 2005 to that in 2006?
Offer a terse response. 0.92. What is the ratio of the Bank branche(per 100,000 adults) in Bolivia in 2005 to that in 2006?
Your answer should be compact. 0.89. What is the ratio of the Bank branche(per 100,000 adults) in Iran in 2005 to that in 2006?
Your response must be concise. 1.01. What is the ratio of the Bank branche(per 100,000 adults) of Lithuania in 2005 to that in 2006?
Your answer should be very brief. 0.91. What is the ratio of the Bank branche(per 100,000 adults) in Azerbaijan in 2005 to that in 2007?
Keep it short and to the point. 0.82. What is the ratio of the Bank branche(per 100,000 adults) of Bolivia in 2005 to that in 2007?
Your response must be concise. 0.86. What is the ratio of the Bank branche(per 100,000 adults) in Lithuania in 2005 to that in 2007?
Offer a very short reply. 0.85. What is the ratio of the Bank branche(per 100,000 adults) of Azerbaijan in 2005 to that in 2008?
Offer a terse response. 0.73. What is the ratio of the Bank branche(per 100,000 adults) in Bolivia in 2005 to that in 2008?
Offer a terse response. 0.81. What is the ratio of the Bank branche(per 100,000 adults) in Iran in 2005 to that in 2008?
Keep it short and to the point. 0.97. What is the ratio of the Bank branche(per 100,000 adults) in Lithuania in 2005 to that in 2008?
Provide a succinct answer. 0.85. What is the ratio of the Bank branche(per 100,000 adults) in Azerbaijan in 2005 to that in 2009?
Your answer should be compact. 0.69. What is the ratio of the Bank branche(per 100,000 adults) of Bolivia in 2005 to that in 2009?
Provide a short and direct response. 0.74. What is the ratio of the Bank branche(per 100,000 adults) in Iran in 2005 to that in 2009?
Your answer should be very brief. 0.98. What is the ratio of the Bank branche(per 100,000 adults) of Lithuania in 2005 to that in 2009?
Your answer should be very brief. 0.85. What is the ratio of the Bank branche(per 100,000 adults) of Azerbaijan in 2005 to that in 2010?
Provide a succinct answer. 0.68. What is the ratio of the Bank branche(per 100,000 adults) in Bolivia in 2005 to that in 2010?
Offer a terse response. 0.6. What is the ratio of the Bank branche(per 100,000 adults) of Iran in 2005 to that in 2010?
Give a very brief answer. 1.07. What is the ratio of the Bank branche(per 100,000 adults) of Lithuania in 2005 to that in 2010?
Provide a succinct answer. 0.86. What is the ratio of the Bank branche(per 100,000 adults) of Azerbaijan in 2006 to that in 2007?
Offer a terse response. 0.89. What is the ratio of the Bank branche(per 100,000 adults) in Bolivia in 2006 to that in 2007?
Offer a very short reply. 0.97. What is the ratio of the Bank branche(per 100,000 adults) of Iran in 2006 to that in 2007?
Your answer should be very brief. 0.99. What is the ratio of the Bank branche(per 100,000 adults) of Lithuania in 2006 to that in 2007?
Provide a short and direct response. 0.93. What is the ratio of the Bank branche(per 100,000 adults) in Azerbaijan in 2006 to that in 2008?
Your answer should be compact. 0.8. What is the ratio of the Bank branche(per 100,000 adults) of Bolivia in 2006 to that in 2008?
Ensure brevity in your answer.  0.91. What is the ratio of the Bank branche(per 100,000 adults) in Iran in 2006 to that in 2008?
Offer a very short reply. 0.97. What is the ratio of the Bank branche(per 100,000 adults) of Lithuania in 2006 to that in 2008?
Provide a short and direct response. 0.93. What is the ratio of the Bank branche(per 100,000 adults) of Azerbaijan in 2006 to that in 2009?
Keep it short and to the point. 0.75. What is the ratio of the Bank branche(per 100,000 adults) in Bolivia in 2006 to that in 2009?
Make the answer very short. 0.83. What is the ratio of the Bank branche(per 100,000 adults) of Iran in 2006 to that in 2009?
Your answer should be compact. 0.97. What is the ratio of the Bank branche(per 100,000 adults) of Lithuania in 2006 to that in 2009?
Ensure brevity in your answer.  0.94. What is the ratio of the Bank branche(per 100,000 adults) in Azerbaijan in 2006 to that in 2010?
Keep it short and to the point. 0.74. What is the ratio of the Bank branche(per 100,000 adults) in Bolivia in 2006 to that in 2010?
Make the answer very short. 0.67. What is the ratio of the Bank branche(per 100,000 adults) in Iran in 2006 to that in 2010?
Ensure brevity in your answer.  1.06. What is the ratio of the Bank branche(per 100,000 adults) of Lithuania in 2006 to that in 2010?
Keep it short and to the point. 0.95. What is the ratio of the Bank branche(per 100,000 adults) of Azerbaijan in 2007 to that in 2008?
Give a very brief answer. 0.89. What is the ratio of the Bank branche(per 100,000 adults) in Bolivia in 2007 to that in 2008?
Your answer should be very brief. 0.94. What is the ratio of the Bank branche(per 100,000 adults) in Iran in 2007 to that in 2008?
Your answer should be compact. 0.97. What is the ratio of the Bank branche(per 100,000 adults) in Lithuania in 2007 to that in 2008?
Give a very brief answer. 1. What is the ratio of the Bank branche(per 100,000 adults) in Azerbaijan in 2007 to that in 2009?
Your answer should be very brief. 0.84. What is the ratio of the Bank branche(per 100,000 adults) of Bolivia in 2007 to that in 2009?
Your answer should be very brief. 0.86. What is the ratio of the Bank branche(per 100,000 adults) of Iran in 2007 to that in 2009?
Provide a short and direct response. 0.98. What is the ratio of the Bank branche(per 100,000 adults) in Azerbaijan in 2007 to that in 2010?
Your answer should be compact. 0.83. What is the ratio of the Bank branche(per 100,000 adults) in Bolivia in 2007 to that in 2010?
Provide a short and direct response. 0.69. What is the ratio of the Bank branche(per 100,000 adults) of Iran in 2007 to that in 2010?
Offer a very short reply. 1.06. What is the ratio of the Bank branche(per 100,000 adults) in Lithuania in 2007 to that in 2010?
Make the answer very short. 1.02. What is the ratio of the Bank branche(per 100,000 adults) of Azerbaijan in 2008 to that in 2009?
Your answer should be compact. 0.94. What is the ratio of the Bank branche(per 100,000 adults) of Bolivia in 2008 to that in 2009?
Provide a succinct answer. 0.91. What is the ratio of the Bank branche(per 100,000 adults) in Iran in 2008 to that in 2009?
Provide a short and direct response. 1.01. What is the ratio of the Bank branche(per 100,000 adults) of Azerbaijan in 2008 to that in 2010?
Your answer should be very brief. 0.93. What is the ratio of the Bank branche(per 100,000 adults) of Bolivia in 2008 to that in 2010?
Your answer should be compact. 0.73. What is the ratio of the Bank branche(per 100,000 adults) of Iran in 2008 to that in 2010?
Provide a short and direct response. 1.09. What is the ratio of the Bank branche(per 100,000 adults) in Lithuania in 2008 to that in 2010?
Your answer should be compact. 1.02. What is the ratio of the Bank branche(per 100,000 adults) in Azerbaijan in 2009 to that in 2010?
Give a very brief answer. 0.99. What is the ratio of the Bank branche(per 100,000 adults) of Bolivia in 2009 to that in 2010?
Offer a very short reply. 0.8. What is the ratio of the Bank branche(per 100,000 adults) of Iran in 2009 to that in 2010?
Your answer should be compact. 1.08. What is the ratio of the Bank branche(per 100,000 adults) in Lithuania in 2009 to that in 2010?
Keep it short and to the point. 1.01. What is the difference between the highest and the second highest Bank branche(per 100,000 adults) in Azerbaijan?
Offer a very short reply. 0.07. What is the difference between the highest and the second highest Bank branche(per 100,000 adults) of Bolivia?
Ensure brevity in your answer.  1.69. What is the difference between the highest and the second highest Bank branche(per 100,000 adults) of Iran?
Make the answer very short. 0.28. What is the difference between the highest and the second highest Bank branche(per 100,000 adults) of Lithuania?
Your answer should be very brief. 0.05. What is the difference between the highest and the lowest Bank branche(per 100,000 adults) in Azerbaijan?
Give a very brief answer. 3.11. What is the difference between the highest and the lowest Bank branche(per 100,000 adults) in Bolivia?
Provide a short and direct response. 3.46. What is the difference between the highest and the lowest Bank branche(per 100,000 adults) of Iran?
Provide a short and direct response. 2.44. 